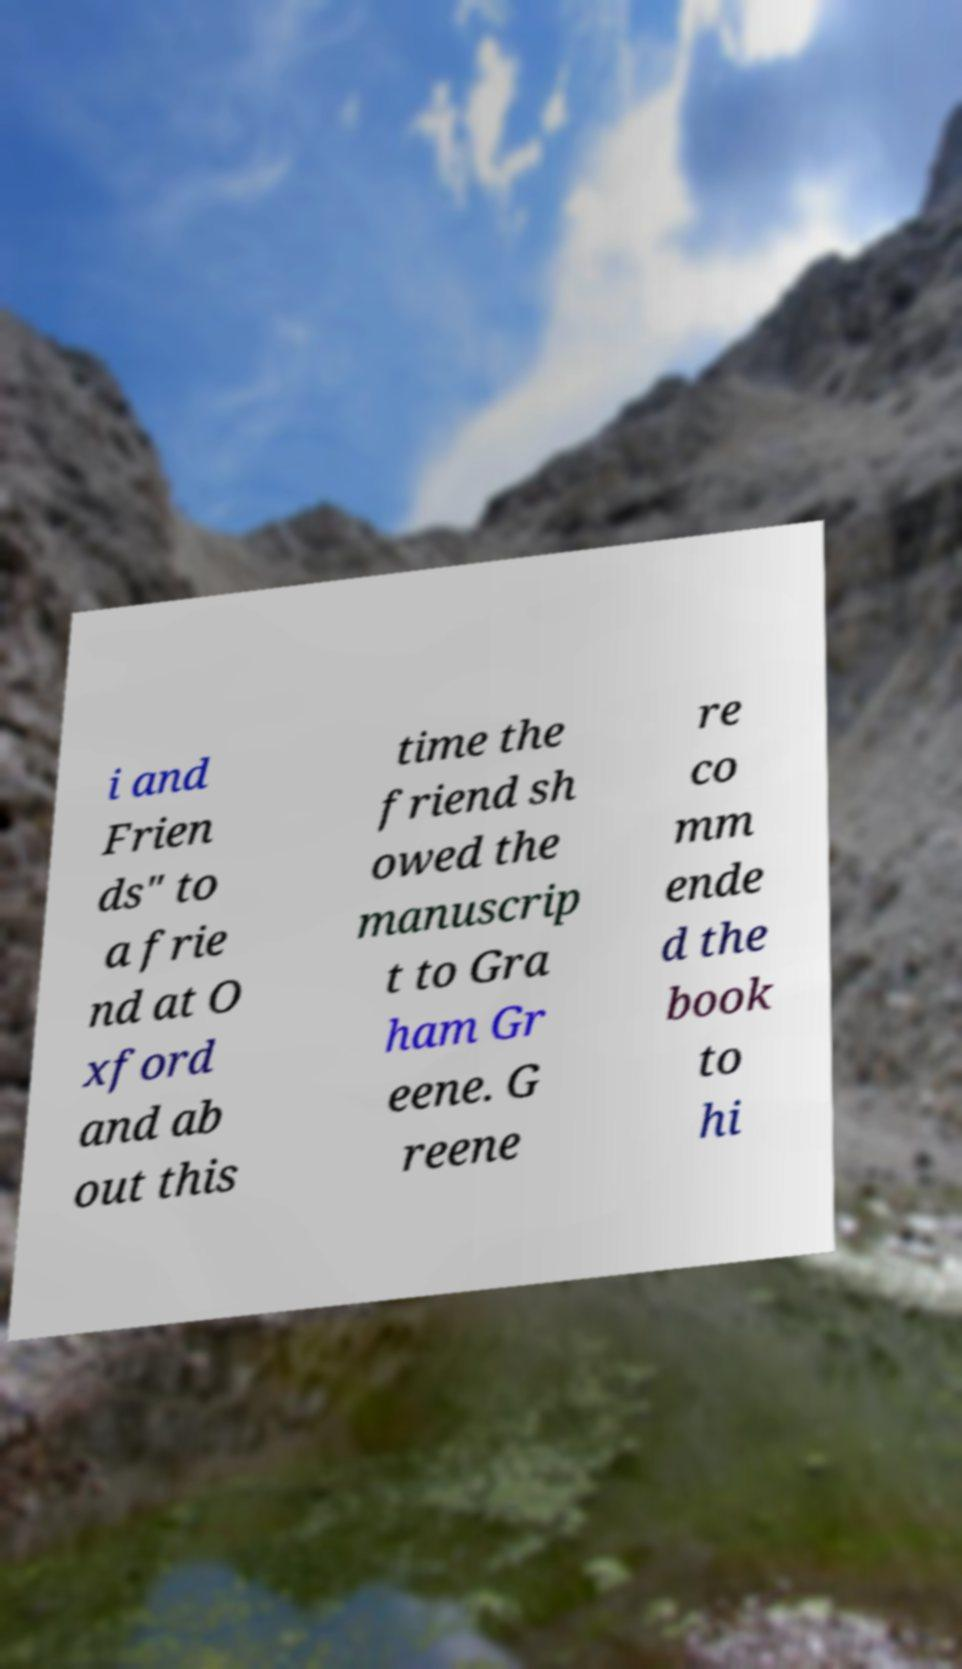Could you assist in decoding the text presented in this image and type it out clearly? i and Frien ds" to a frie nd at O xford and ab out this time the friend sh owed the manuscrip t to Gra ham Gr eene. G reene re co mm ende d the book to hi 